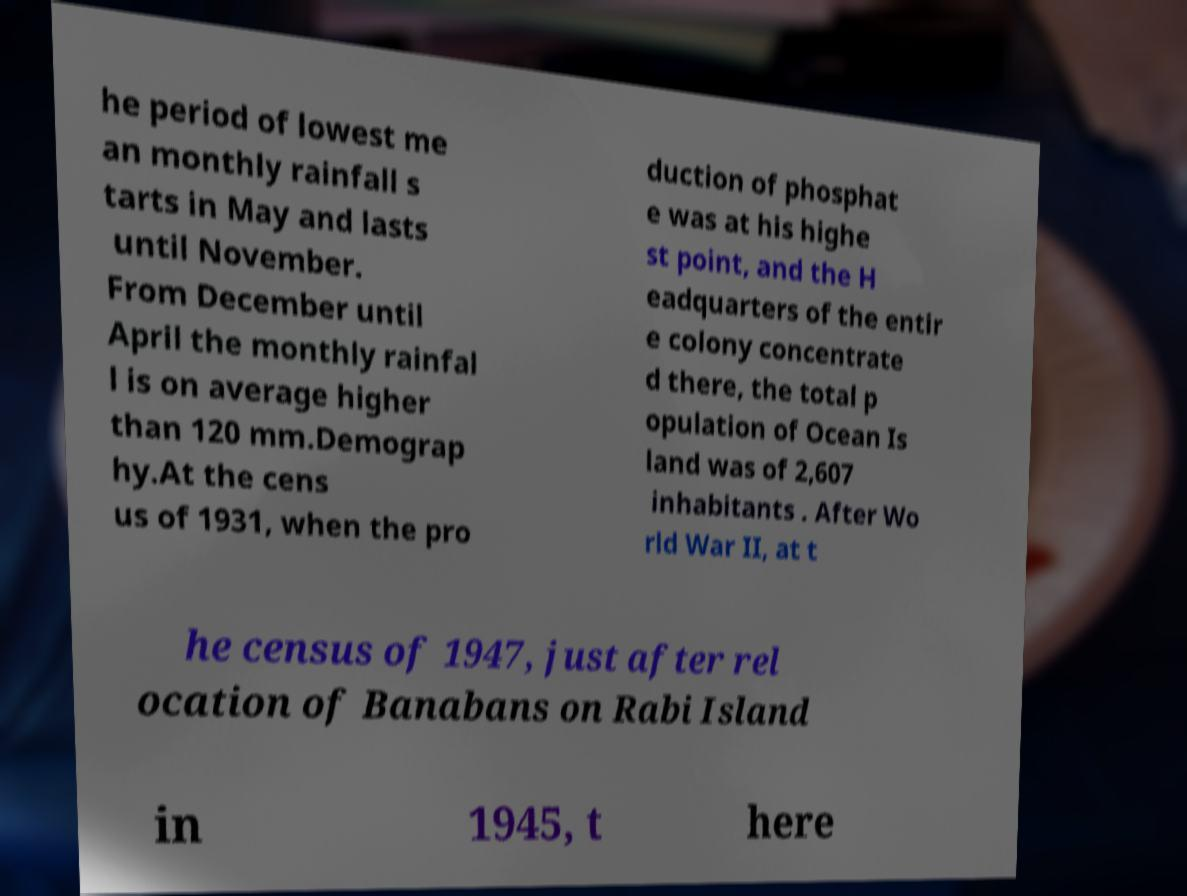What messages or text are displayed in this image? I need them in a readable, typed format. he period of lowest me an monthly rainfall s tarts in May and lasts until November. From December until April the monthly rainfal l is on average higher than 120 mm.Demograp hy.At the cens us of 1931, when the pro duction of phosphat e was at his highe st point, and the H eadquarters of the entir e colony concentrate d there, the total p opulation of Ocean Is land was of 2,607 inhabitants . After Wo rld War II, at t he census of 1947, just after rel ocation of Banabans on Rabi Island in 1945, t here 